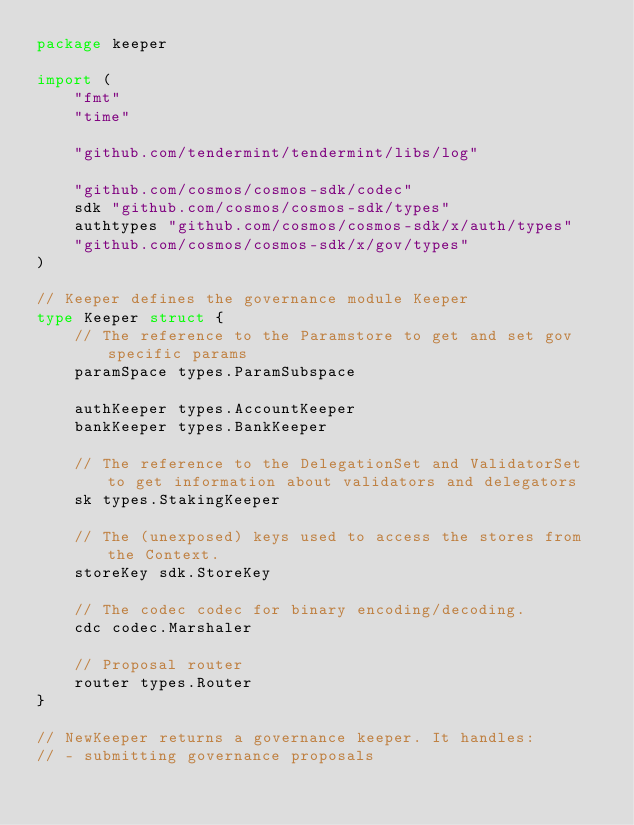<code> <loc_0><loc_0><loc_500><loc_500><_Go_>package keeper

import (
	"fmt"
	"time"

	"github.com/tendermint/tendermint/libs/log"

	"github.com/cosmos/cosmos-sdk/codec"
	sdk "github.com/cosmos/cosmos-sdk/types"
	authtypes "github.com/cosmos/cosmos-sdk/x/auth/types"
	"github.com/cosmos/cosmos-sdk/x/gov/types"
)

// Keeper defines the governance module Keeper
type Keeper struct {
	// The reference to the Paramstore to get and set gov specific params
	paramSpace types.ParamSubspace

	authKeeper types.AccountKeeper
	bankKeeper types.BankKeeper

	// The reference to the DelegationSet and ValidatorSet to get information about validators and delegators
	sk types.StakingKeeper

	// The (unexposed) keys used to access the stores from the Context.
	storeKey sdk.StoreKey

	// The codec codec for binary encoding/decoding.
	cdc codec.Marshaler

	// Proposal router
	router types.Router
}

// NewKeeper returns a governance keeper. It handles:
// - submitting governance proposals</code> 